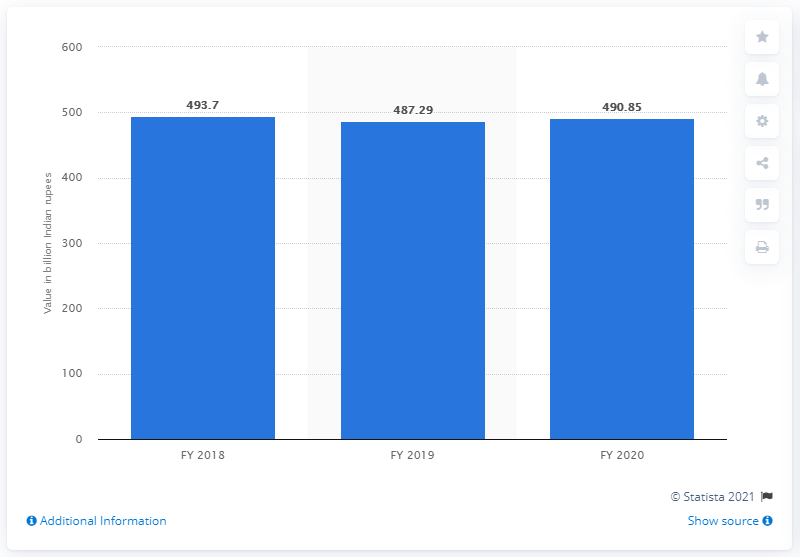Highlight a few significant elements in this photo. Union Bank of India's gross non-performing assets (NPAs) amounted to 490.85 crore rupees at the end of fiscal year 2020. 